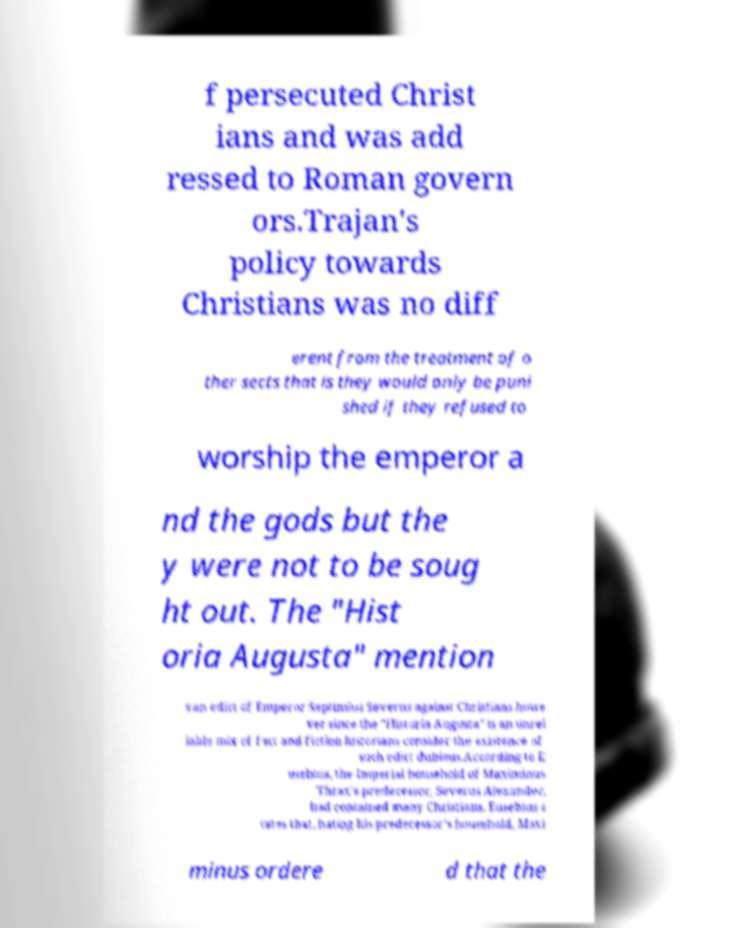What messages or text are displayed in this image? I need them in a readable, typed format. f persecuted Christ ians and was add ressed to Roman govern ors.Trajan's policy towards Christians was no diff erent from the treatment of o ther sects that is they would only be puni shed if they refused to worship the emperor a nd the gods but the y were not to be soug ht out. The "Hist oria Augusta" mention s an edict of Emperor Septimius Severus against Christians howe ver since the "Historia Augusta" is an unrel iable mix of fact and fiction historians consider the existence of such edict dubious.According to E usebius, the Imperial household of Maximinus Thrax's predecessor, Severus Alexander, had contained many Christians. Eusebius s tates that, hating his predecessor's household, Maxi minus ordere d that the 